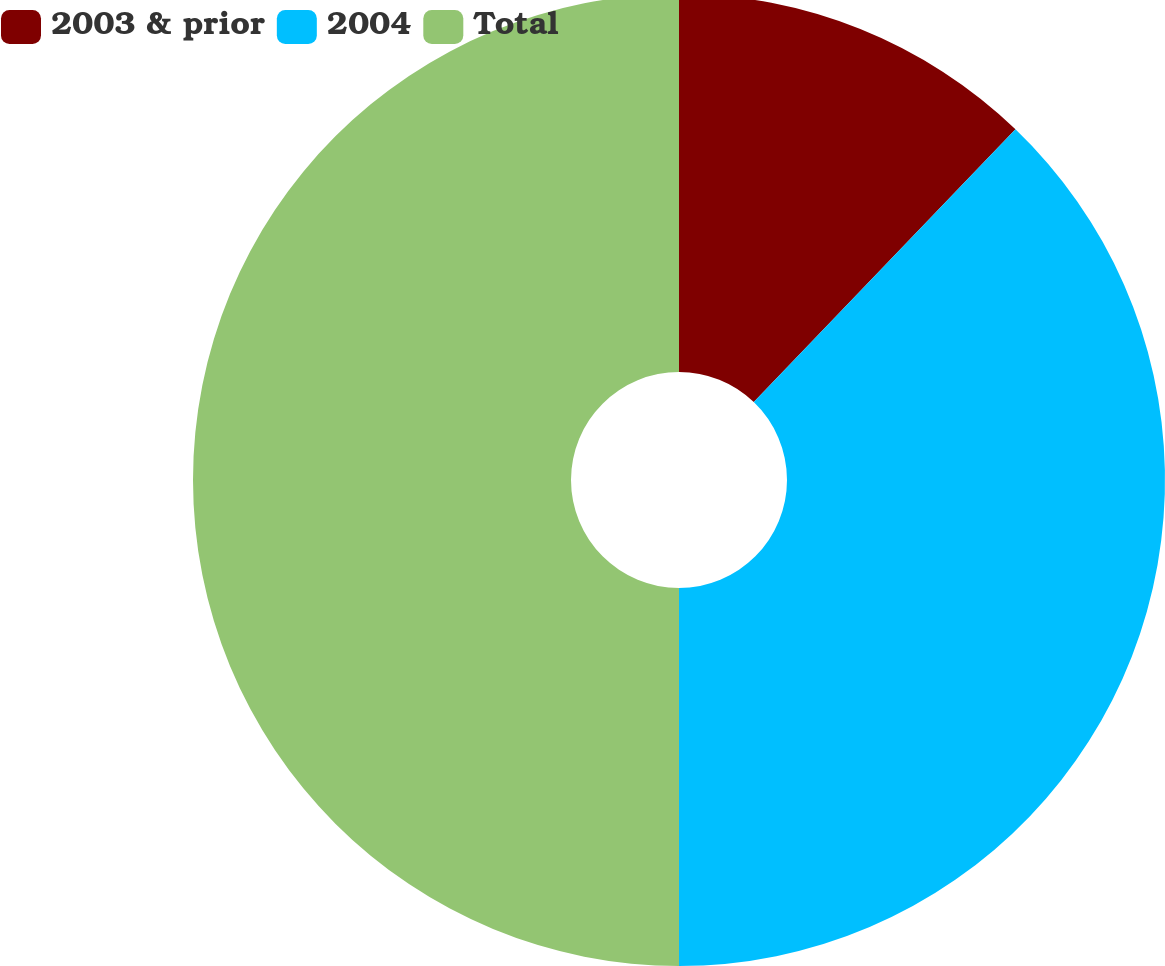Convert chart to OTSL. <chart><loc_0><loc_0><loc_500><loc_500><pie_chart><fcel>2003 & prior<fcel>2004<fcel>Total<nl><fcel>12.17%<fcel>37.83%<fcel>50.0%<nl></chart> 